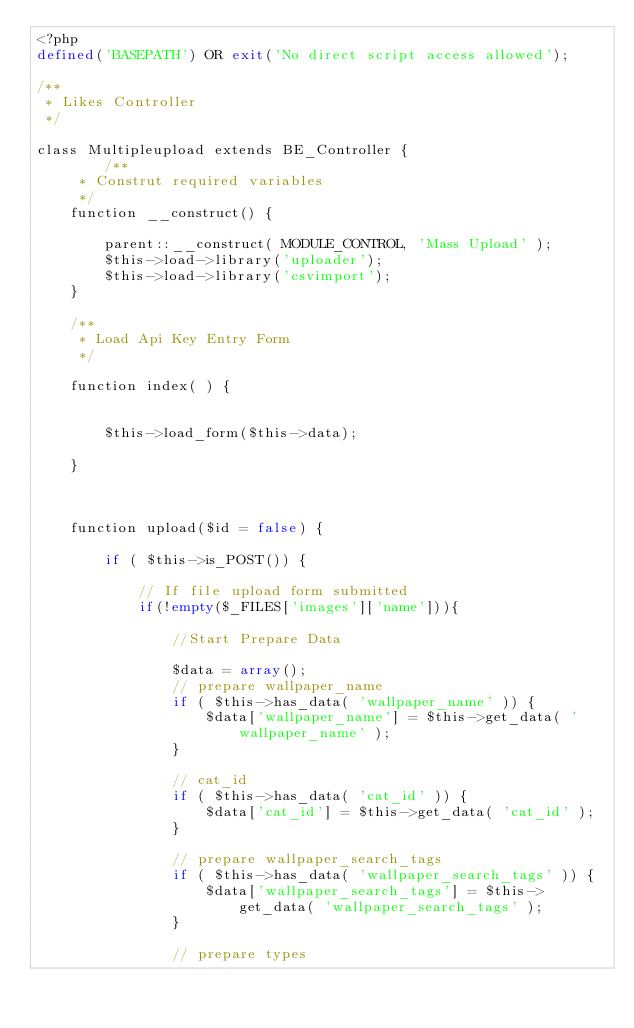<code> <loc_0><loc_0><loc_500><loc_500><_PHP_><?php
defined('BASEPATH') OR exit('No direct script access allowed');

/**
 * Likes Controller
 */

class Multipleupload extends BE_Controller {
		/**
	 * Construt required variables
	 */
	function __construct() {

		parent::__construct( MODULE_CONTROL, 'Mass Upload' );
		$this->load->library('uploader');
		$this->load->library('csvimport');
	}

	/**
	 * Load Api Key Entry Form
	 */

	function index( ) {

		
		$this->load_form($this->data);

	}

	

	function upload($id = false) {
		
		if ( $this->is_POST()) {

			// If file upload form submitted
	        if(!empty($_FILES['images']['name'])){
	            
	        	//Start Prepare Data

	        	$data = array();
	        	// prepare wallpaper_name
				if ( $this->has_data( 'wallpaper_name' )) {
					$data['wallpaper_name'] = $this->get_data( 'wallpaper_name' );
				}

				// cat_id
				if ( $this->has_data( 'cat_id' )) {
					$data['cat_id'] = $this->get_data( 'cat_id' );
				}

				// prepare wallpaper_search_tags
				if ( $this->has_data( 'wallpaper_search_tags' )) {
					$data['wallpaper_search_tags'] = $this->get_data( 'wallpaper_search_tags' );
				}

				// prepare types</code> 